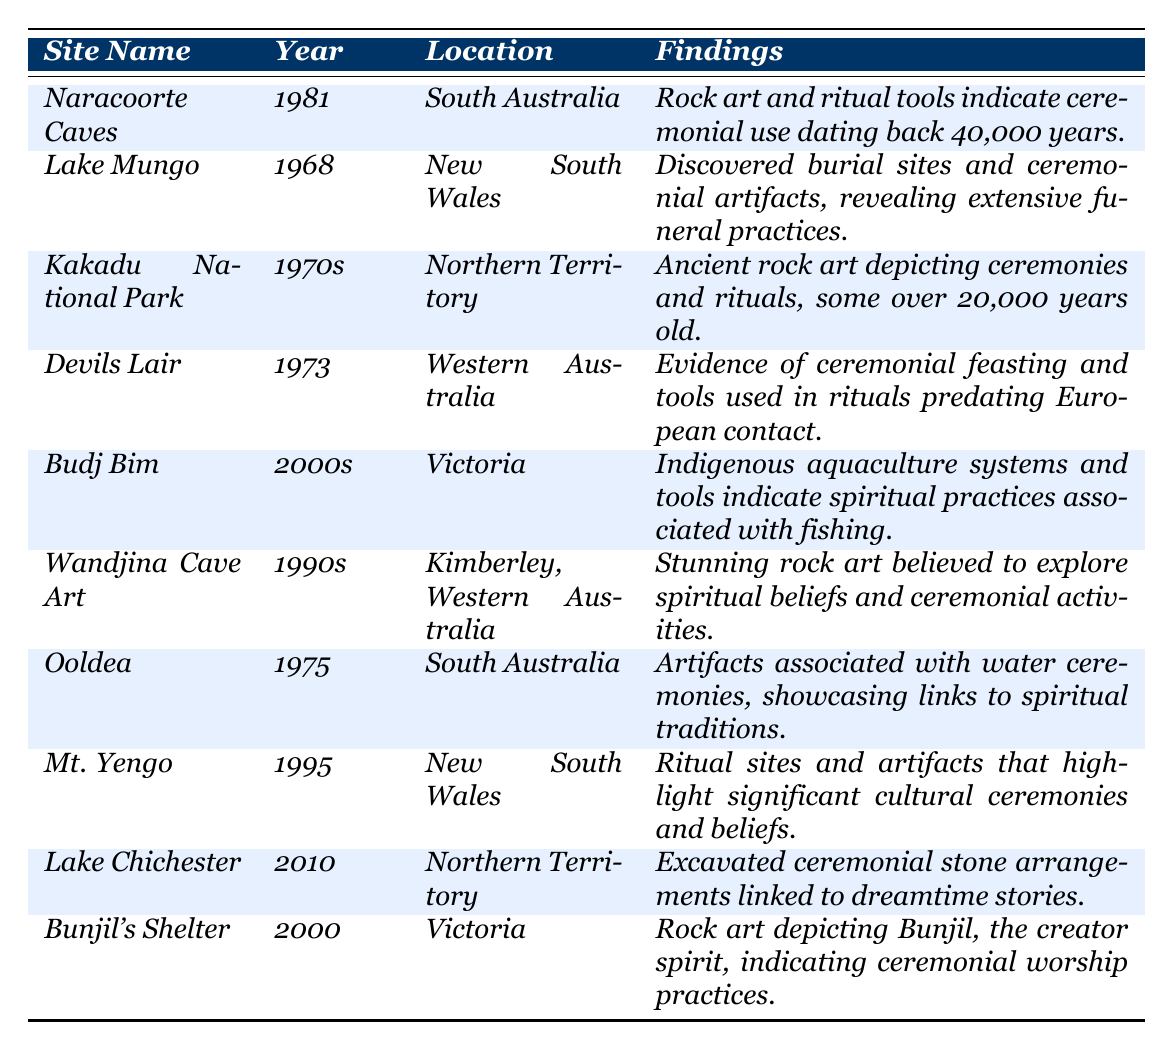What is the name of the site excavated in 1981? The table specifies that the site excavated in 1981 is Naracoorte Caves.
Answer: Naracoorte Caves How many sites were excavated in the 2000s? There are two sites listed with excavation years in the 2000s: Budj Bim and Bunjil's Shelter.
Answer: 2 What findings were discovered at Lake Mungo? The findings at Lake Mungo include burial sites and ceremonial artifacts indicating extensive funeral practices.
Answer: Burial sites and ceremonial artifacts Is there any evidence of ritual tools found at Devils Lair? Yes, the findings at Devils Lair include evidence of ceremonial feasting and tools used in rituals, confirming the existence of ritual tools.
Answer: Yes Which site contains rock art that indicates ceremonial use dating back 40,000 years? The site that contains rock art indicating ceremonial use dating back 40,000 years is Naracoorte Caves.
Answer: Naracoorte Caves In how many states in Australia were excavations conducted? The table lists excavations from sites across five different states: South Australia, New South Wales, Northern Territory, Western Australia, and Victoria, confirming five states.
Answer: 5 What is the primary focus of the findings at Budj Bim? The primary focus of the findings at Budj Bim is on Indigenous aquaculture systems and tools linked to spiritual practices associated with fishing.
Answer: Aquaculture systems and spiritual practices Which site has findings related to dreamtime stories? The site with findings linked to dreamtime stories is Lake Chichester, as it has excavated ceremonial stone arrangements associated with them.
Answer: Lake Chichester Among the listed sites, what is the earliest excavation year mentioned? The earliest excavation year mentioned in the table is 1968, for Lake Mungo.
Answer: 1968 What type of ceremonial practices are indicated by the findings at Ooldea? The findings at Ooldea showcase artifacts associated with water ceremonies, indicating links to spiritual traditions.
Answer: Water ceremonies 